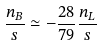<formula> <loc_0><loc_0><loc_500><loc_500>\frac { n _ { B } } { s } \simeq - \frac { 2 8 } { 7 9 } \frac { n _ { L } } { s }</formula> 